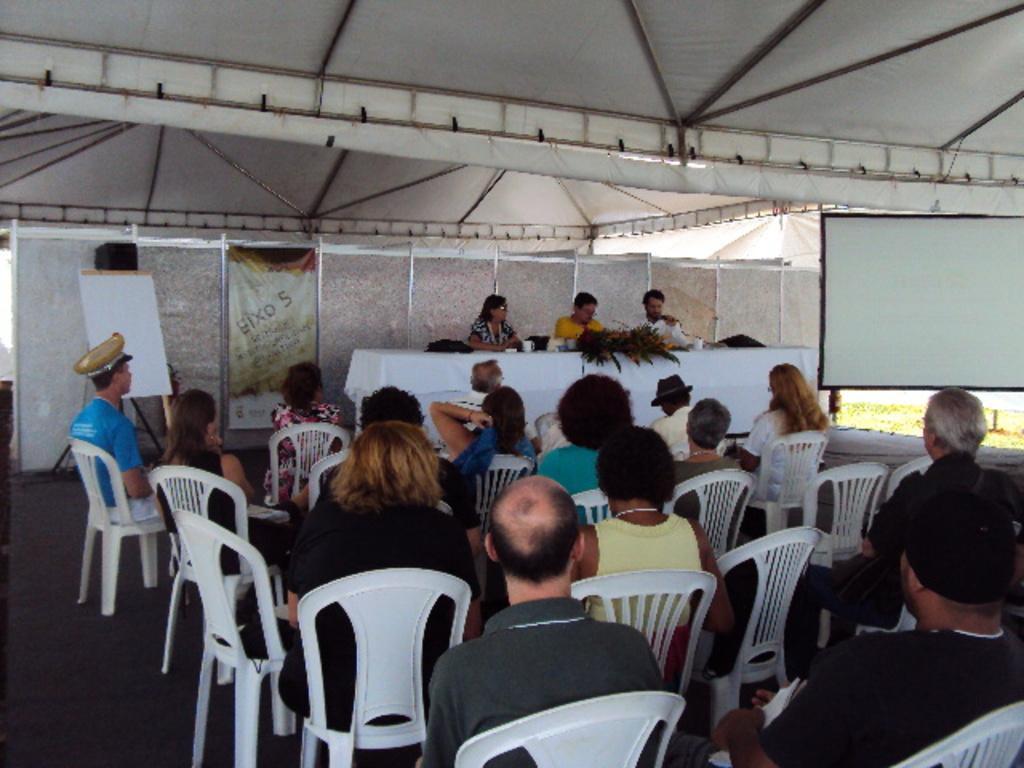Please provide a concise description of this image. In the image we can see there are lot of people who are sitting on chair and few people are sitting on stage. 